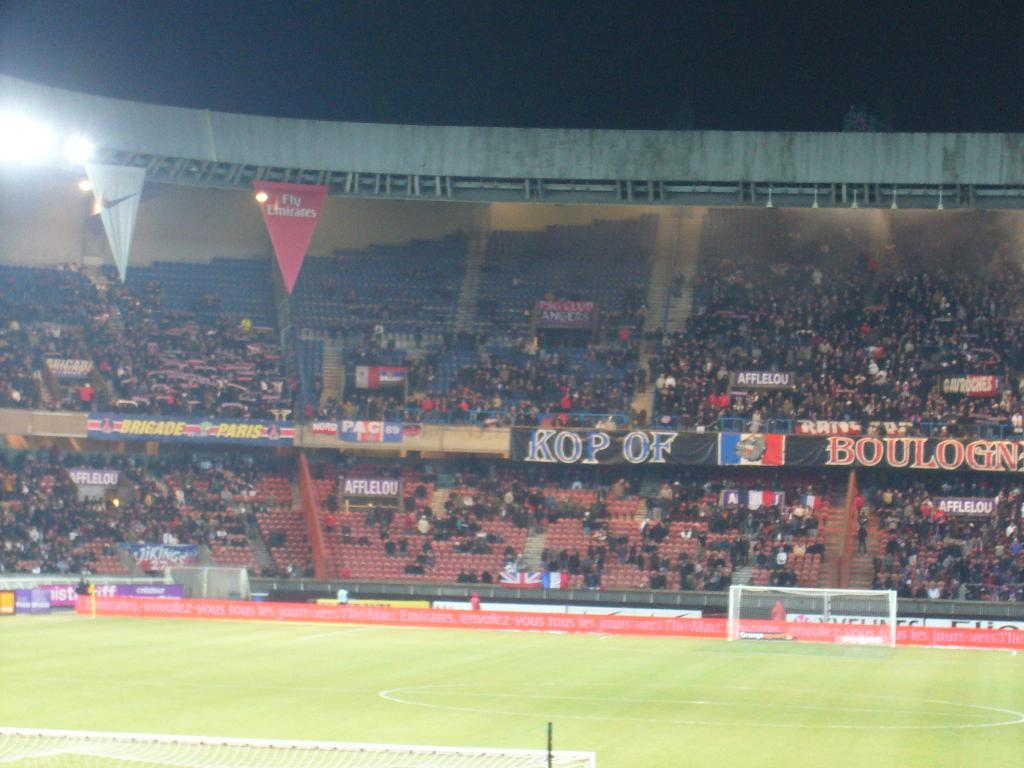What type of surface can be seen in the image? There is ground visible in the image. What kind of structure is present in the image? There is a mesh in the image. What type of advertisement or signage is present in the image? Hoardings are present in the image. What can be seen illuminating the area in the image? Lights are visible in the image. What type of furniture is in the image? Chairs are in the image. Are there any people present in the image? Yes, people are in the image. How would you describe the lighting at the top of the image? The top of the image is dark. Can you tell me how many roots are visible in the image? There are no roots present in the image. What type of judge is depicted in the image? There is no judge depicted in the image. 